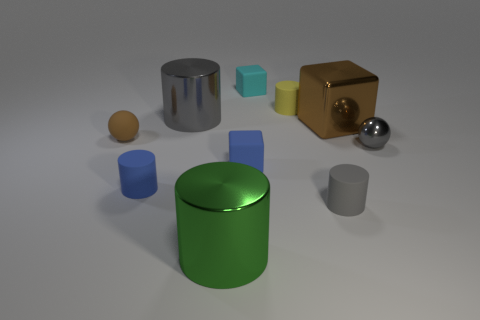Are there the same number of large blocks in front of the small gray metallic sphere and small cyan cubes? There are not an equal number of large blocks in front of the small gray metallic sphere and the small cyan cubes. Upon observing the image, we find two large blue cylinders positioned in front of one small cyan cube, while there are no large blocks directly in front of the small gray metallic sphere. 